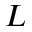Convert formula to latex. <formula><loc_0><loc_0><loc_500><loc_500>L</formula> 